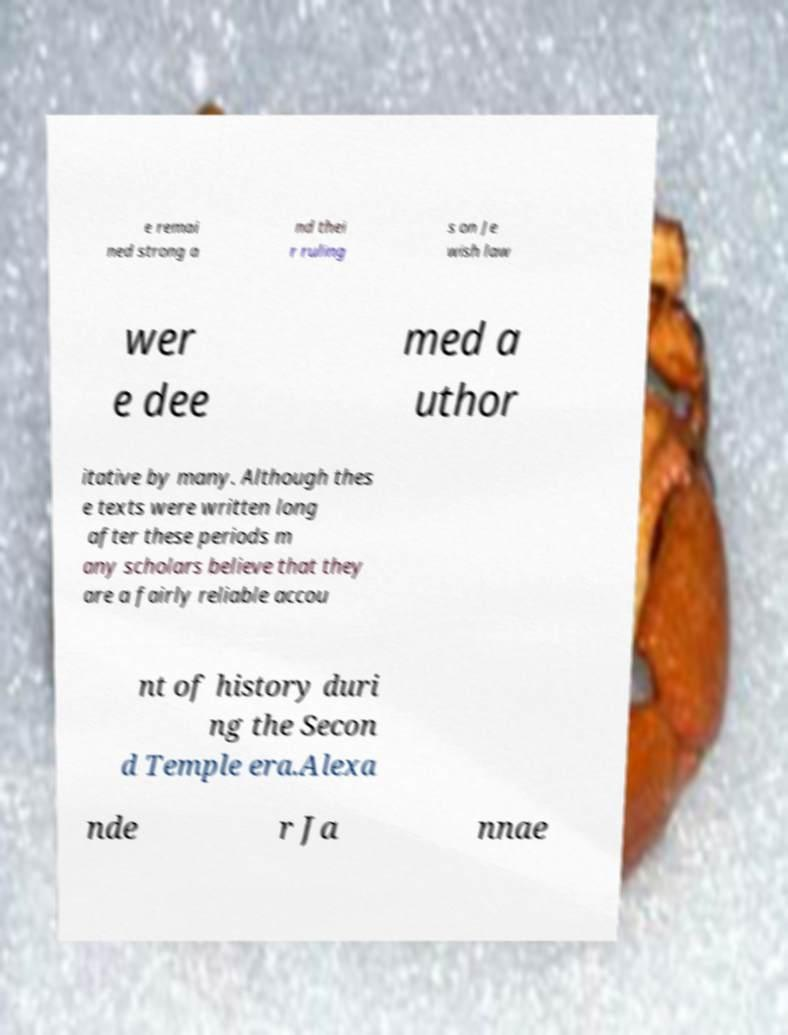Can you accurately transcribe the text from the provided image for me? e remai ned strong a nd thei r ruling s on Je wish law wer e dee med a uthor itative by many. Although thes e texts were written long after these periods m any scholars believe that they are a fairly reliable accou nt of history duri ng the Secon d Temple era.Alexa nde r Ja nnae 